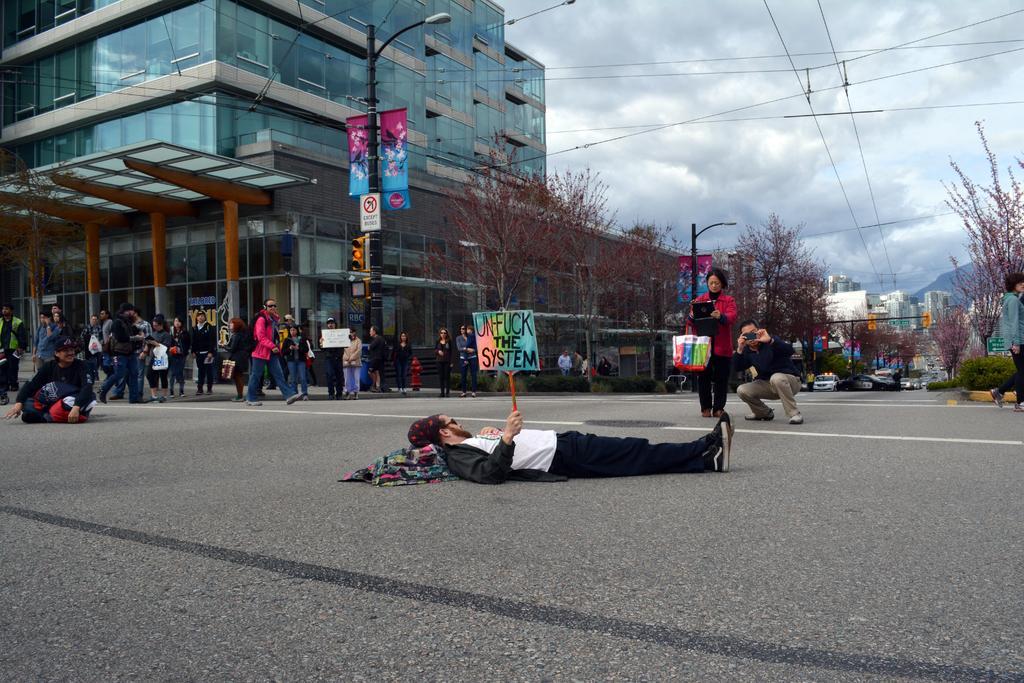Could you give a brief overview of what you see in this image? In this picture we can see a person holding a bard and lying on the path. We can see a few people from left to right. There is a streetlight, few trees and buildings in the background. Some wires are visible on top. Sky is cloudy. 